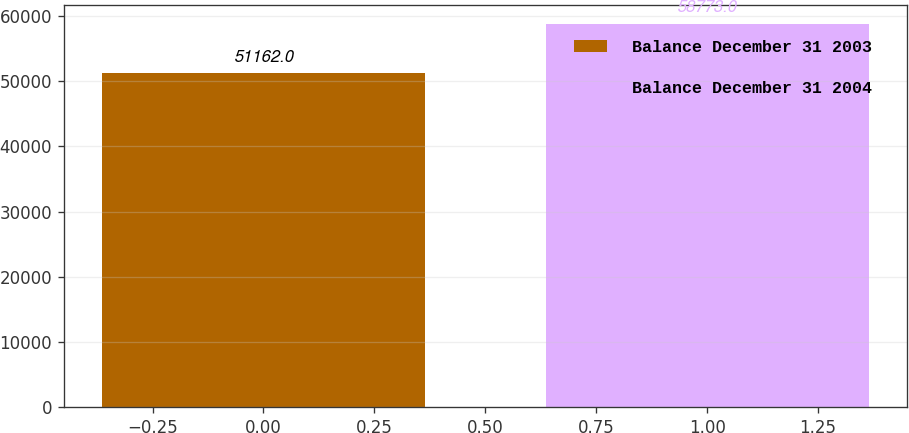<chart> <loc_0><loc_0><loc_500><loc_500><bar_chart><fcel>Balance December 31 2003<fcel>Balance December 31 2004<nl><fcel>51162<fcel>58773<nl></chart> 